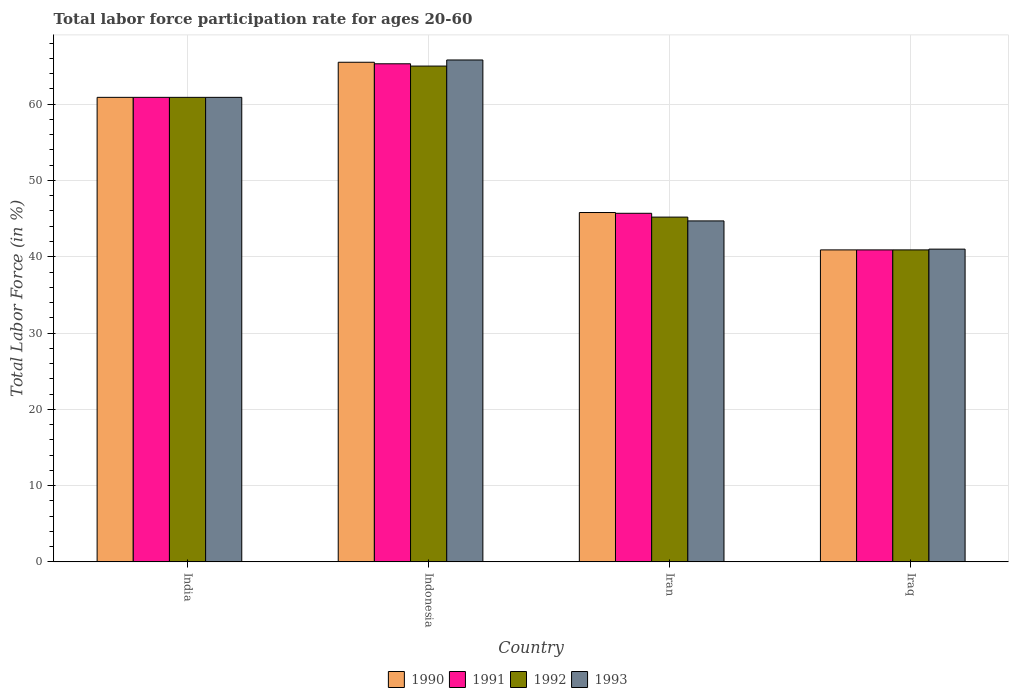How many different coloured bars are there?
Your answer should be compact. 4. How many groups of bars are there?
Your answer should be compact. 4. What is the label of the 2nd group of bars from the left?
Your answer should be compact. Indonesia. What is the labor force participation rate in 1990 in India?
Your answer should be compact. 60.9. Across all countries, what is the maximum labor force participation rate in 1993?
Provide a succinct answer. 65.8. Across all countries, what is the minimum labor force participation rate in 1990?
Ensure brevity in your answer.  40.9. In which country was the labor force participation rate in 1993 minimum?
Provide a short and direct response. Iraq. What is the total labor force participation rate in 1991 in the graph?
Ensure brevity in your answer.  212.8. What is the difference between the labor force participation rate in 1991 in India and that in Indonesia?
Make the answer very short. -4.4. What is the average labor force participation rate in 1991 per country?
Ensure brevity in your answer.  53.2. What is the difference between the labor force participation rate of/in 1992 and labor force participation rate of/in 1993 in Iraq?
Give a very brief answer. -0.1. In how many countries, is the labor force participation rate in 1990 greater than 58 %?
Offer a terse response. 2. What is the ratio of the labor force participation rate in 1990 in Indonesia to that in Iraq?
Give a very brief answer. 1.6. Is the difference between the labor force participation rate in 1992 in India and Iran greater than the difference between the labor force participation rate in 1993 in India and Iran?
Provide a succinct answer. No. What is the difference between the highest and the second highest labor force participation rate in 1993?
Provide a succinct answer. 4.9. What is the difference between the highest and the lowest labor force participation rate in 1990?
Offer a very short reply. 24.6. In how many countries, is the labor force participation rate in 1993 greater than the average labor force participation rate in 1993 taken over all countries?
Keep it short and to the point. 2. Is the sum of the labor force participation rate in 1992 in Indonesia and Iraq greater than the maximum labor force participation rate in 1991 across all countries?
Keep it short and to the point. Yes. Is it the case that in every country, the sum of the labor force participation rate in 1992 and labor force participation rate in 1993 is greater than the sum of labor force participation rate in 1991 and labor force participation rate in 1990?
Keep it short and to the point. No. What does the 4th bar from the left in Iran represents?
Keep it short and to the point. 1993. What does the 3rd bar from the right in Iraq represents?
Provide a short and direct response. 1991. Is it the case that in every country, the sum of the labor force participation rate in 1990 and labor force participation rate in 1992 is greater than the labor force participation rate in 1993?
Offer a very short reply. Yes. Are all the bars in the graph horizontal?
Make the answer very short. No. How many countries are there in the graph?
Ensure brevity in your answer.  4. Does the graph contain any zero values?
Give a very brief answer. No. Where does the legend appear in the graph?
Your answer should be very brief. Bottom center. How are the legend labels stacked?
Your answer should be very brief. Horizontal. What is the title of the graph?
Give a very brief answer. Total labor force participation rate for ages 20-60. Does "2007" appear as one of the legend labels in the graph?
Your answer should be compact. No. What is the label or title of the X-axis?
Make the answer very short. Country. What is the Total Labor Force (in %) of 1990 in India?
Offer a very short reply. 60.9. What is the Total Labor Force (in %) in 1991 in India?
Give a very brief answer. 60.9. What is the Total Labor Force (in %) in 1992 in India?
Your response must be concise. 60.9. What is the Total Labor Force (in %) in 1993 in India?
Make the answer very short. 60.9. What is the Total Labor Force (in %) of 1990 in Indonesia?
Your answer should be compact. 65.5. What is the Total Labor Force (in %) in 1991 in Indonesia?
Your response must be concise. 65.3. What is the Total Labor Force (in %) of 1992 in Indonesia?
Make the answer very short. 65. What is the Total Labor Force (in %) of 1993 in Indonesia?
Provide a short and direct response. 65.8. What is the Total Labor Force (in %) of 1990 in Iran?
Ensure brevity in your answer.  45.8. What is the Total Labor Force (in %) of 1991 in Iran?
Your answer should be compact. 45.7. What is the Total Labor Force (in %) of 1992 in Iran?
Your answer should be very brief. 45.2. What is the Total Labor Force (in %) of 1993 in Iran?
Keep it short and to the point. 44.7. What is the Total Labor Force (in %) of 1990 in Iraq?
Provide a succinct answer. 40.9. What is the Total Labor Force (in %) of 1991 in Iraq?
Offer a very short reply. 40.9. What is the Total Labor Force (in %) of 1992 in Iraq?
Offer a terse response. 40.9. What is the Total Labor Force (in %) in 1993 in Iraq?
Your response must be concise. 41. Across all countries, what is the maximum Total Labor Force (in %) of 1990?
Your answer should be compact. 65.5. Across all countries, what is the maximum Total Labor Force (in %) of 1991?
Offer a terse response. 65.3. Across all countries, what is the maximum Total Labor Force (in %) of 1993?
Your response must be concise. 65.8. Across all countries, what is the minimum Total Labor Force (in %) in 1990?
Offer a terse response. 40.9. Across all countries, what is the minimum Total Labor Force (in %) in 1991?
Make the answer very short. 40.9. Across all countries, what is the minimum Total Labor Force (in %) of 1992?
Keep it short and to the point. 40.9. What is the total Total Labor Force (in %) of 1990 in the graph?
Make the answer very short. 213.1. What is the total Total Labor Force (in %) of 1991 in the graph?
Provide a succinct answer. 212.8. What is the total Total Labor Force (in %) of 1992 in the graph?
Offer a very short reply. 212. What is the total Total Labor Force (in %) of 1993 in the graph?
Provide a short and direct response. 212.4. What is the difference between the Total Labor Force (in %) of 1993 in India and that in Indonesia?
Your answer should be very brief. -4.9. What is the difference between the Total Labor Force (in %) in 1991 in India and that in Iran?
Provide a succinct answer. 15.2. What is the difference between the Total Labor Force (in %) in 1993 in India and that in Iran?
Offer a terse response. 16.2. What is the difference between the Total Labor Force (in %) in 1992 in India and that in Iraq?
Provide a short and direct response. 20. What is the difference between the Total Labor Force (in %) of 1990 in Indonesia and that in Iran?
Your answer should be compact. 19.7. What is the difference between the Total Labor Force (in %) of 1991 in Indonesia and that in Iran?
Make the answer very short. 19.6. What is the difference between the Total Labor Force (in %) of 1992 in Indonesia and that in Iran?
Your answer should be compact. 19.8. What is the difference between the Total Labor Force (in %) in 1993 in Indonesia and that in Iran?
Give a very brief answer. 21.1. What is the difference between the Total Labor Force (in %) of 1990 in Indonesia and that in Iraq?
Give a very brief answer. 24.6. What is the difference between the Total Labor Force (in %) of 1991 in Indonesia and that in Iraq?
Keep it short and to the point. 24.4. What is the difference between the Total Labor Force (in %) in 1992 in Indonesia and that in Iraq?
Offer a very short reply. 24.1. What is the difference between the Total Labor Force (in %) in 1993 in Indonesia and that in Iraq?
Offer a terse response. 24.8. What is the difference between the Total Labor Force (in %) of 1990 in Iran and that in Iraq?
Your answer should be compact. 4.9. What is the difference between the Total Labor Force (in %) of 1990 in India and the Total Labor Force (in %) of 1991 in Indonesia?
Keep it short and to the point. -4.4. What is the difference between the Total Labor Force (in %) of 1990 in India and the Total Labor Force (in %) of 1992 in Indonesia?
Provide a short and direct response. -4.1. What is the difference between the Total Labor Force (in %) in 1991 in India and the Total Labor Force (in %) in 1993 in Indonesia?
Make the answer very short. -4.9. What is the difference between the Total Labor Force (in %) of 1992 in India and the Total Labor Force (in %) of 1993 in Indonesia?
Offer a very short reply. -4.9. What is the difference between the Total Labor Force (in %) in 1990 in India and the Total Labor Force (in %) in 1991 in Iran?
Make the answer very short. 15.2. What is the difference between the Total Labor Force (in %) of 1990 in India and the Total Labor Force (in %) of 1993 in Iran?
Provide a short and direct response. 16.2. What is the difference between the Total Labor Force (in %) in 1991 in India and the Total Labor Force (in %) in 1992 in Iran?
Offer a terse response. 15.7. What is the difference between the Total Labor Force (in %) of 1991 in India and the Total Labor Force (in %) of 1992 in Iraq?
Keep it short and to the point. 20. What is the difference between the Total Labor Force (in %) of 1990 in Indonesia and the Total Labor Force (in %) of 1991 in Iran?
Ensure brevity in your answer.  19.8. What is the difference between the Total Labor Force (in %) of 1990 in Indonesia and the Total Labor Force (in %) of 1992 in Iran?
Keep it short and to the point. 20.3. What is the difference between the Total Labor Force (in %) of 1990 in Indonesia and the Total Labor Force (in %) of 1993 in Iran?
Give a very brief answer. 20.8. What is the difference between the Total Labor Force (in %) in 1991 in Indonesia and the Total Labor Force (in %) in 1992 in Iran?
Offer a very short reply. 20.1. What is the difference between the Total Labor Force (in %) of 1991 in Indonesia and the Total Labor Force (in %) of 1993 in Iran?
Your answer should be compact. 20.6. What is the difference between the Total Labor Force (in %) in 1992 in Indonesia and the Total Labor Force (in %) in 1993 in Iran?
Make the answer very short. 20.3. What is the difference between the Total Labor Force (in %) in 1990 in Indonesia and the Total Labor Force (in %) in 1991 in Iraq?
Make the answer very short. 24.6. What is the difference between the Total Labor Force (in %) in 1990 in Indonesia and the Total Labor Force (in %) in 1992 in Iraq?
Offer a very short reply. 24.6. What is the difference between the Total Labor Force (in %) of 1991 in Indonesia and the Total Labor Force (in %) of 1992 in Iraq?
Ensure brevity in your answer.  24.4. What is the difference between the Total Labor Force (in %) in 1991 in Indonesia and the Total Labor Force (in %) in 1993 in Iraq?
Give a very brief answer. 24.3. What is the difference between the Total Labor Force (in %) of 1992 in Indonesia and the Total Labor Force (in %) of 1993 in Iraq?
Your answer should be compact. 24. What is the difference between the Total Labor Force (in %) in 1990 in Iran and the Total Labor Force (in %) in 1991 in Iraq?
Provide a succinct answer. 4.9. What is the difference between the Total Labor Force (in %) of 1990 in Iran and the Total Labor Force (in %) of 1992 in Iraq?
Provide a short and direct response. 4.9. What is the difference between the Total Labor Force (in %) in 1990 in Iran and the Total Labor Force (in %) in 1993 in Iraq?
Your answer should be compact. 4.8. What is the average Total Labor Force (in %) in 1990 per country?
Offer a terse response. 53.27. What is the average Total Labor Force (in %) in 1991 per country?
Your answer should be compact. 53.2. What is the average Total Labor Force (in %) in 1993 per country?
Your answer should be compact. 53.1. What is the difference between the Total Labor Force (in %) in 1990 and Total Labor Force (in %) in 1991 in India?
Ensure brevity in your answer.  0. What is the difference between the Total Labor Force (in %) in 1990 and Total Labor Force (in %) in 1992 in India?
Provide a succinct answer. 0. What is the difference between the Total Labor Force (in %) in 1990 and Total Labor Force (in %) in 1993 in India?
Your answer should be compact. 0. What is the difference between the Total Labor Force (in %) of 1991 and Total Labor Force (in %) of 1992 in India?
Offer a terse response. 0. What is the difference between the Total Labor Force (in %) in 1992 and Total Labor Force (in %) in 1993 in India?
Your answer should be compact. 0. What is the difference between the Total Labor Force (in %) of 1990 and Total Labor Force (in %) of 1991 in Indonesia?
Keep it short and to the point. 0.2. What is the difference between the Total Labor Force (in %) in 1990 and Total Labor Force (in %) in 1992 in Indonesia?
Make the answer very short. 0.5. What is the difference between the Total Labor Force (in %) in 1992 and Total Labor Force (in %) in 1993 in Indonesia?
Make the answer very short. -0.8. What is the difference between the Total Labor Force (in %) in 1991 and Total Labor Force (in %) in 1993 in Iran?
Provide a succinct answer. 1. What is the difference between the Total Labor Force (in %) of 1990 and Total Labor Force (in %) of 1991 in Iraq?
Give a very brief answer. 0. What is the difference between the Total Labor Force (in %) of 1990 and Total Labor Force (in %) of 1992 in Iraq?
Offer a very short reply. 0. What is the difference between the Total Labor Force (in %) of 1990 and Total Labor Force (in %) of 1993 in Iraq?
Your answer should be very brief. -0.1. What is the difference between the Total Labor Force (in %) in 1991 and Total Labor Force (in %) in 1992 in Iraq?
Your response must be concise. 0. What is the difference between the Total Labor Force (in %) in 1992 and Total Labor Force (in %) in 1993 in Iraq?
Your answer should be compact. -0.1. What is the ratio of the Total Labor Force (in %) of 1990 in India to that in Indonesia?
Offer a very short reply. 0.93. What is the ratio of the Total Labor Force (in %) of 1991 in India to that in Indonesia?
Provide a succinct answer. 0.93. What is the ratio of the Total Labor Force (in %) of 1992 in India to that in Indonesia?
Provide a succinct answer. 0.94. What is the ratio of the Total Labor Force (in %) in 1993 in India to that in Indonesia?
Offer a terse response. 0.93. What is the ratio of the Total Labor Force (in %) of 1990 in India to that in Iran?
Provide a succinct answer. 1.33. What is the ratio of the Total Labor Force (in %) in 1991 in India to that in Iran?
Provide a succinct answer. 1.33. What is the ratio of the Total Labor Force (in %) in 1992 in India to that in Iran?
Ensure brevity in your answer.  1.35. What is the ratio of the Total Labor Force (in %) in 1993 in India to that in Iran?
Make the answer very short. 1.36. What is the ratio of the Total Labor Force (in %) in 1990 in India to that in Iraq?
Give a very brief answer. 1.49. What is the ratio of the Total Labor Force (in %) in 1991 in India to that in Iraq?
Provide a short and direct response. 1.49. What is the ratio of the Total Labor Force (in %) in 1992 in India to that in Iraq?
Provide a succinct answer. 1.49. What is the ratio of the Total Labor Force (in %) in 1993 in India to that in Iraq?
Offer a terse response. 1.49. What is the ratio of the Total Labor Force (in %) of 1990 in Indonesia to that in Iran?
Your answer should be compact. 1.43. What is the ratio of the Total Labor Force (in %) of 1991 in Indonesia to that in Iran?
Your answer should be compact. 1.43. What is the ratio of the Total Labor Force (in %) of 1992 in Indonesia to that in Iran?
Your response must be concise. 1.44. What is the ratio of the Total Labor Force (in %) in 1993 in Indonesia to that in Iran?
Offer a terse response. 1.47. What is the ratio of the Total Labor Force (in %) in 1990 in Indonesia to that in Iraq?
Your response must be concise. 1.6. What is the ratio of the Total Labor Force (in %) of 1991 in Indonesia to that in Iraq?
Offer a very short reply. 1.6. What is the ratio of the Total Labor Force (in %) of 1992 in Indonesia to that in Iraq?
Your response must be concise. 1.59. What is the ratio of the Total Labor Force (in %) in 1993 in Indonesia to that in Iraq?
Your answer should be compact. 1.6. What is the ratio of the Total Labor Force (in %) in 1990 in Iran to that in Iraq?
Ensure brevity in your answer.  1.12. What is the ratio of the Total Labor Force (in %) in 1991 in Iran to that in Iraq?
Offer a terse response. 1.12. What is the ratio of the Total Labor Force (in %) in 1992 in Iran to that in Iraq?
Ensure brevity in your answer.  1.11. What is the ratio of the Total Labor Force (in %) in 1993 in Iran to that in Iraq?
Your answer should be compact. 1.09. What is the difference between the highest and the second highest Total Labor Force (in %) of 1991?
Your response must be concise. 4.4. What is the difference between the highest and the second highest Total Labor Force (in %) in 1992?
Provide a succinct answer. 4.1. What is the difference between the highest and the lowest Total Labor Force (in %) in 1990?
Keep it short and to the point. 24.6. What is the difference between the highest and the lowest Total Labor Force (in %) in 1991?
Your answer should be compact. 24.4. What is the difference between the highest and the lowest Total Labor Force (in %) in 1992?
Your answer should be very brief. 24.1. What is the difference between the highest and the lowest Total Labor Force (in %) in 1993?
Offer a terse response. 24.8. 